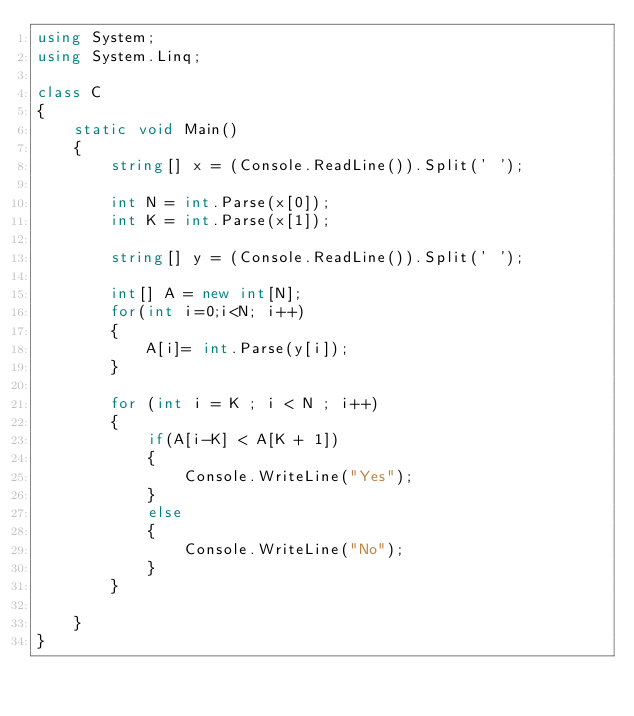<code> <loc_0><loc_0><loc_500><loc_500><_C#_>using System;
using System.Linq;

class C
{
    static void Main()
    {
        string[] x = (Console.ReadLine()).Split(' ');
        
        int N = int.Parse(x[0]);
        int K = int.Parse(x[1]);

        string[] y = (Console.ReadLine()).Split(' ');

        int[] A = new int[N];
        for(int i=0;i<N; i++)
        {
            A[i]= int.Parse(y[i]);
        }

        for (int i = K ; i < N ; i++)
        {
            if(A[i-K] < A[K + 1])
            {
                Console.WriteLine("Yes");
            }
            else
            {
                Console.WriteLine("No");
            }
        }

    }
}</code> 